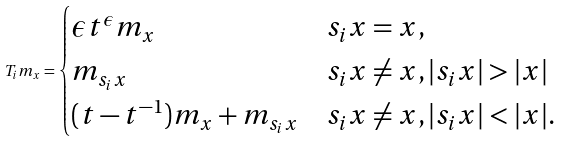Convert formula to latex. <formula><loc_0><loc_0><loc_500><loc_500>T _ { i } m _ { x } = \begin{cases} \epsilon t ^ { \epsilon } m _ { x } & s _ { i } x = x , \\ m _ { s _ { i } x } & s _ { i } x \ne x , | s _ { i } x | > | x | \\ ( t - t ^ { - 1 } ) m _ { x } + m _ { s _ { i } x } & s _ { i } x \ne x , | s _ { i } x | < | x | . \\ \end{cases}</formula> 